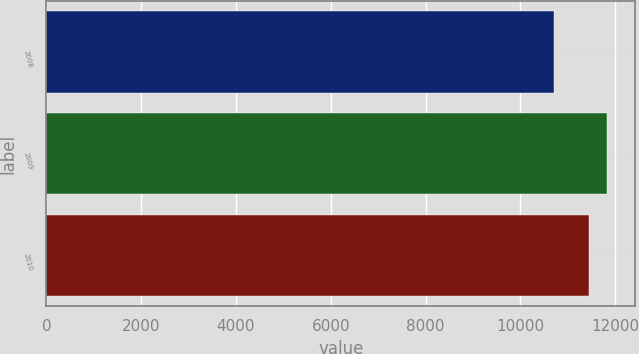Convert chart. <chart><loc_0><loc_0><loc_500><loc_500><bar_chart><fcel>2008<fcel>2009<fcel>2010<nl><fcel>10702<fcel>11832<fcel>11448<nl></chart> 